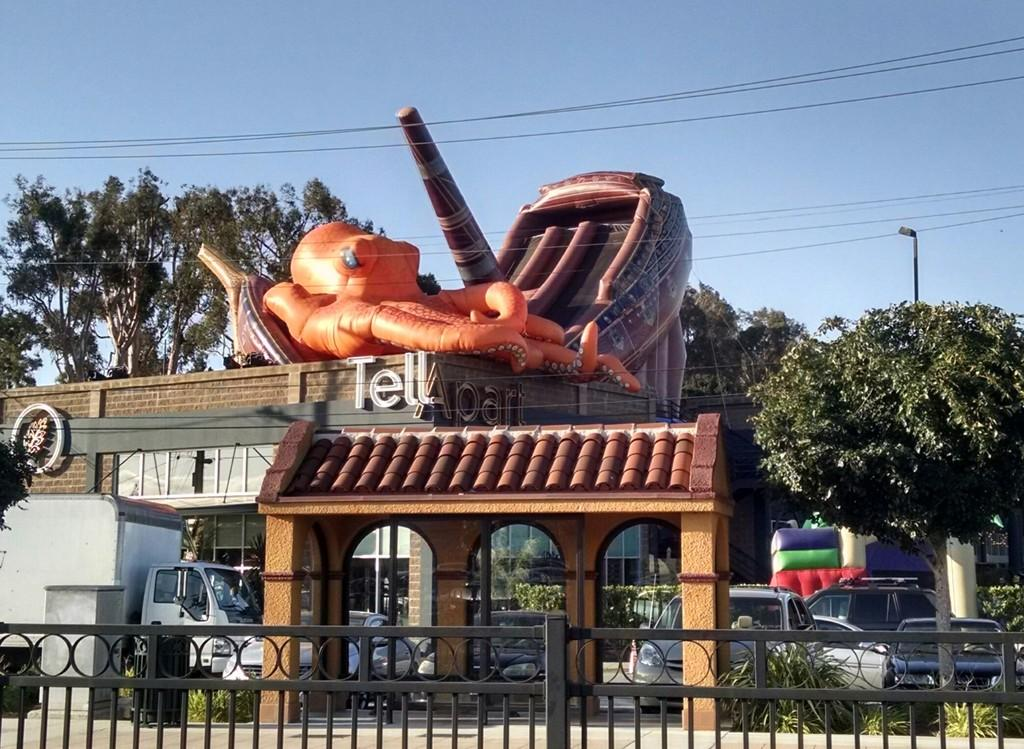What type of natural elements can be seen in the image? There are trees and plants visible in the image. What type of man-made structures are present in the image? There are buildings and railings visible in the image. What is the purpose of the light pole in the image? The light pole provides illumination in the image. What type of infrastructure is present in the image? There are wires and a road visible in the image. What is visible at the top of the image? The sky is visible at the top of the image. What type of floor can be seen in the image? There is no floor present in the image; it is an outdoor scene with a road at the bottom. How does the air circulate in the image? The image does not provide information about air circulation; it only shows the sky, trees, buildings, and other elements. 